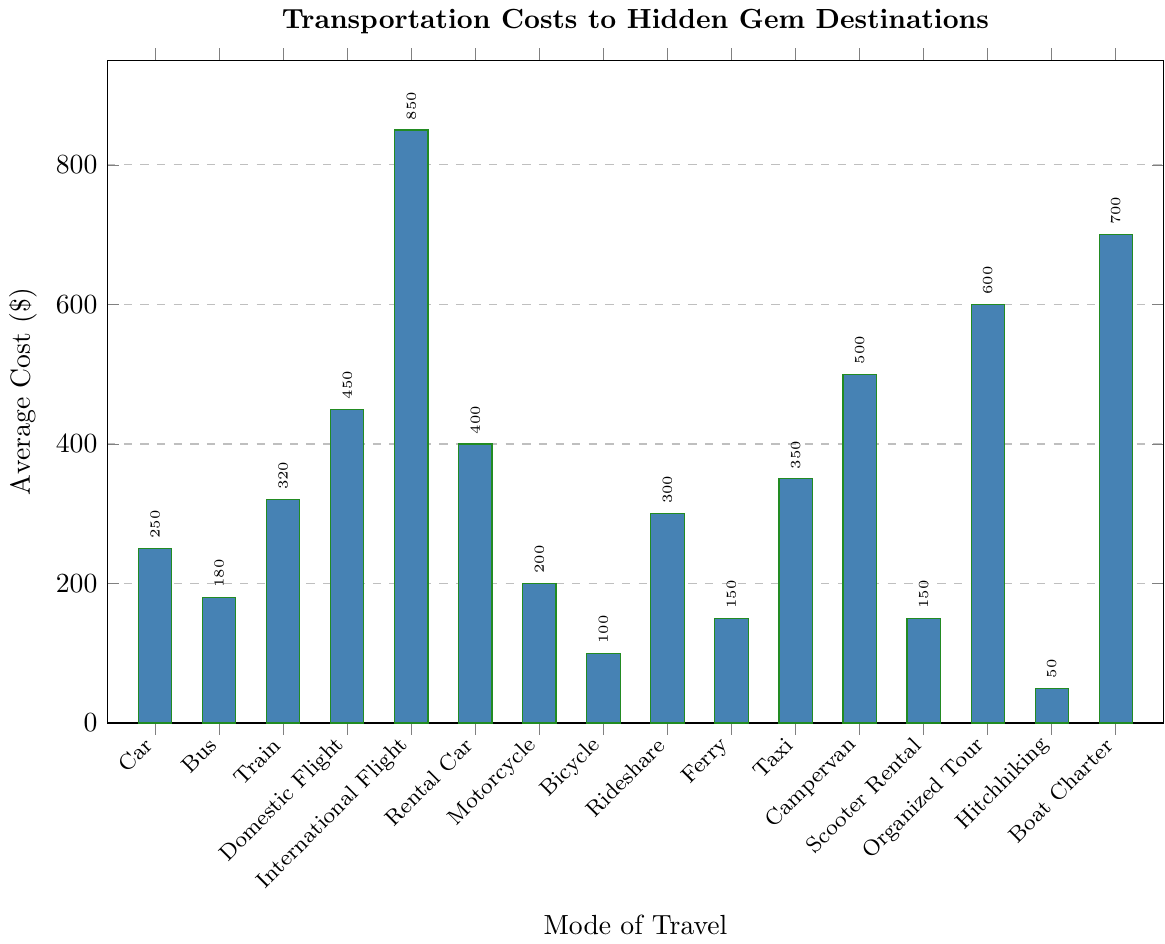Which mode of travel has the highest average cost? From the figure, locate the bar reaching the highest point on the y-axis. This bar corresponds to the "International Flight," indicating it has the highest average cost.
Answer: International Flight Which mode of travel is the most cost-effective? Identify the shortest bar in the figure. The "Hitchhiking" bar is the shortest, indicating it has the lowest average cost.
Answer: Hitchhiking What is the average cost difference between a Domestic Flight and a Bus? From the figure, the cost for a Domestic Flight is $450 and for a Bus is $180. Subtract the cost of the Bus from the cost of the Domestic Flight: 450 - 180 = 270.
Answer: 270 If you add up the average costs of renting a Car and a Campervan, what is the total? From the figure, the cost of a Rental Car is $400 and a Campervan is $500. Adding them up: 400 + 500 = 900.
Answer: 900 How much more expensive is riding an Organized Tour compared to renting a Scooter? From the figure, the cost of an Organized Tour is $600 and a Scooter Rental is $150. Subtract the cost of Scooter Rental from the cost of an Organized Tour: 600 - 150 = 450.
Answer: 450 Which has a higher average cost, a Taxi or Rideshare? Comparing the heights of the bars, the bar for Taxi reaches $350, and the Rideshare reaches $300. This shows that a Taxi is more expensive than a Rideshare.
Answer: Taxi What is the combined average cost of traveling by Motorcycle and Train? From the figure, the cost for a Motorcycle is $200 and for a Train is $320. Adding them up: 200 + 320 = 520.
Answer: 520 Between a Ferry and a Boat Charter, which is cheaper and by how much? From the figure, the cost for a Ferry is $150 and for a Boat Charter is $700. Subtract the cost of a Ferry from a Boat Charter: 700 - 150 = 550.
Answer: Ferry, 550 Which three modes of travel have an average cost above $700? Identify the bars that exceed the $700 mark on the y-axis. The "International Flight," "Boat Charter," and "Organized Tour" bars are above $700.
Answer: International Flight, Boat Charter, Organized Tour What is the difference in average cost between the cheapest and the most expensive modes of travel? The cheapest mode is Hitchhiking at $50, and the most expensive is International Flight at $850. Subtract the cost of Hitchhiking from the cost of International Flight: 850 - 50 = 800.
Answer: 800 